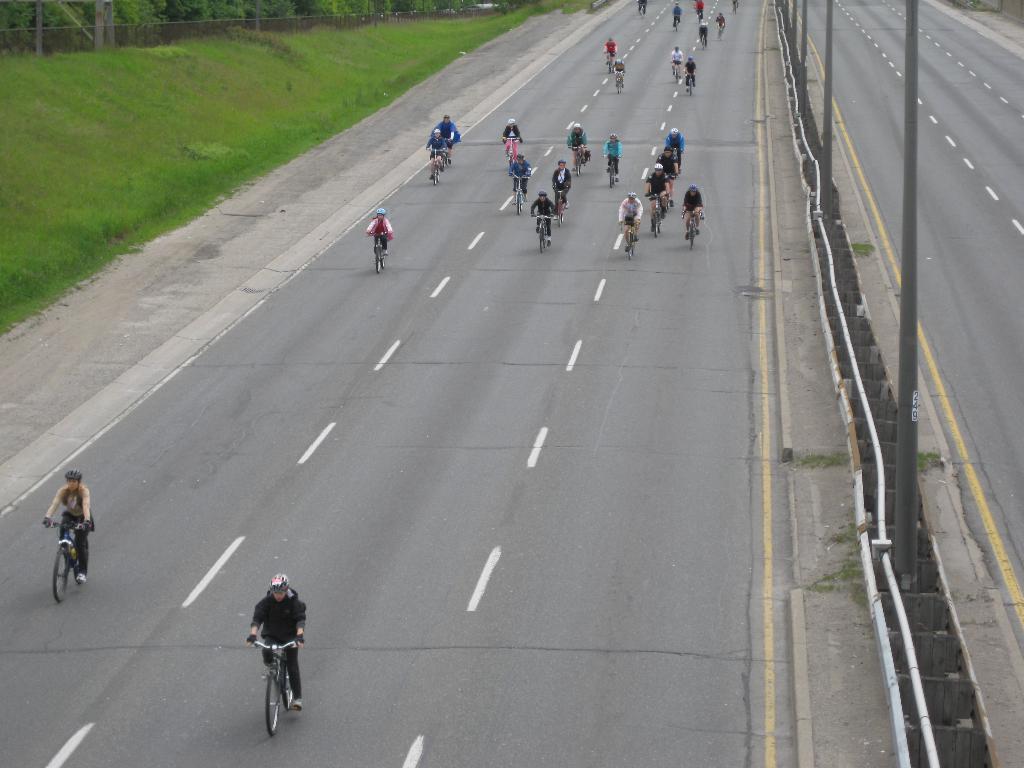How would you summarize this image in a sentence or two? In this image we can see persons riding the bicycles on the road. In the background we can see street poles, pipelines, footpath, grass, fence and trees. 